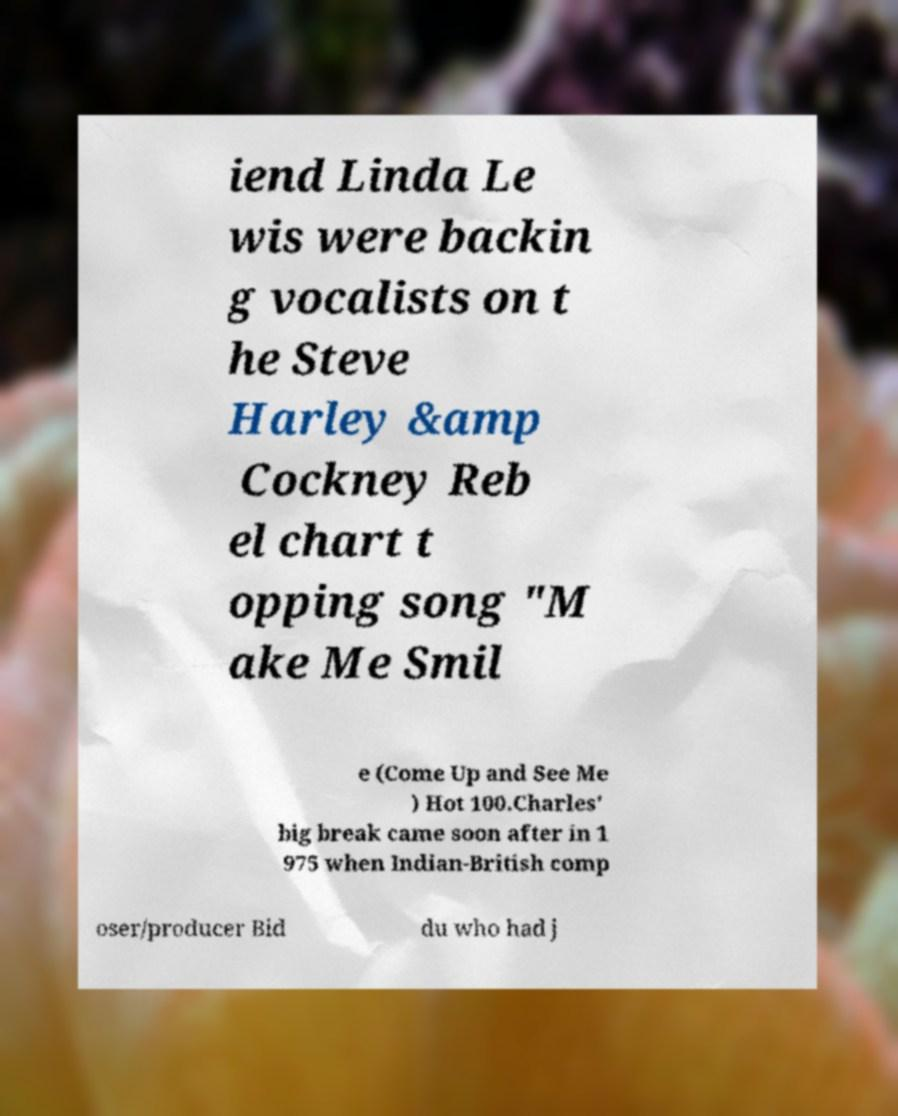There's text embedded in this image that I need extracted. Can you transcribe it verbatim? iend Linda Le wis were backin g vocalists on t he Steve Harley &amp Cockney Reb el chart t opping song "M ake Me Smil e (Come Up and See Me ) Hot 100.Charles' big break came soon after in 1 975 when Indian-British comp oser/producer Bid du who had j 